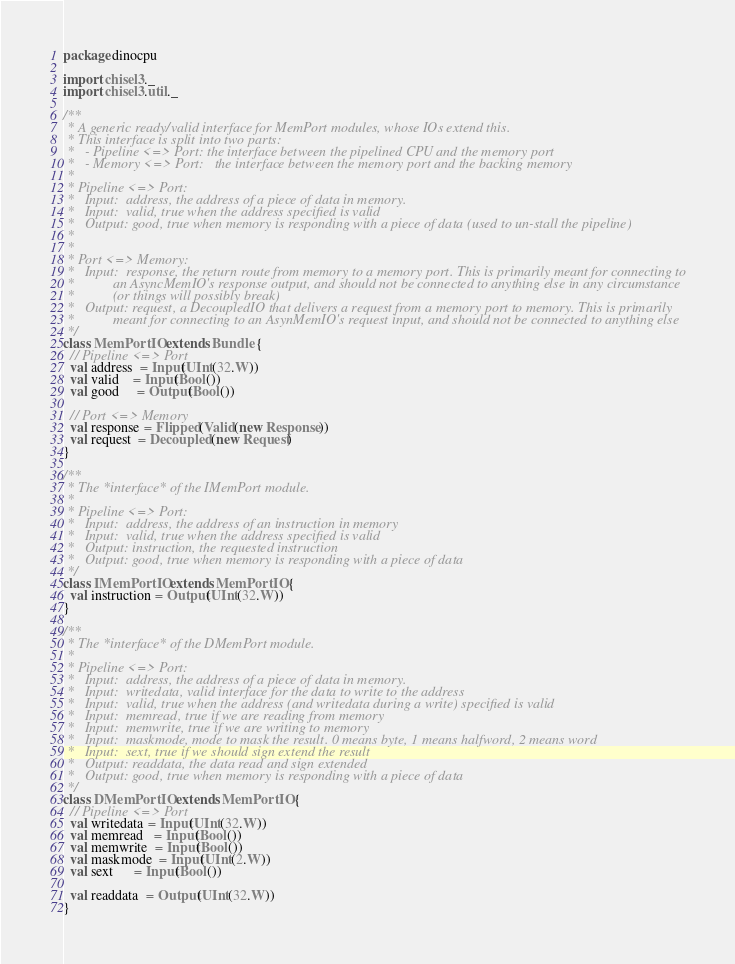<code> <loc_0><loc_0><loc_500><loc_500><_Scala_>
package dinocpu

import chisel3._
import chisel3.util._

/**
 * A generic ready/valid interface for MemPort modules, whose IOs extend this.
 * This interface is split into two parts:
 *   - Pipeline <=> Port: the interface between the pipelined CPU and the memory port
 *   - Memory <=> Port:   the interface between the memory port and the backing memory
 *
 * Pipeline <=> Port:
 *   Input:  address, the address of a piece of data in memory.
 *   Input:  valid, true when the address specified is valid
 *   Output: good, true when memory is responding with a piece of data (used to un-stall the pipeline)
 *
 *
 * Port <=> Memory:
 *   Input:  response, the return route from memory to a memory port. This is primarily meant for connecting to
 *           an AsyncMemIO's response output, and should not be connected to anything else in any circumstance
 *           (or things will possibly break)
 *   Output: request, a DecoupledIO that delivers a request from a memory port to memory. This is primarily
 *           meant for connecting to an AsynMemIO's request input, and should not be connected to anything else
 */
class MemPortIO extends Bundle {
  // Pipeline <=> Port
  val address  = Input(UInt(32.W))
  val valid    = Input(Bool())
  val good     = Output(Bool())

  // Port <=> Memory
  val response = Flipped(Valid(new Response))
  val request  = Decoupled(new Request)
}

/**
 * The *interface* of the IMemPort module.
 *
 * Pipeline <=> Port:
 *   Input:  address, the address of an instruction in memory
 *   Input:  valid, true when the address specified is valid
 *   Output: instruction, the requested instruction
 *   Output: good, true when memory is responding with a piece of data
 */
class IMemPortIO extends MemPortIO {
  val instruction = Output(UInt(32.W))
}

/**
 * The *interface* of the DMemPort module.
 *
 * Pipeline <=> Port:
 *   Input:  address, the address of a piece of data in memory.
 *   Input:  writedata, valid interface for the data to write to the address
 *   Input:  valid, true when the address (and writedata during a write) specified is valid
 *   Input:  memread, true if we are reading from memory
 *   Input:  memwrite, true if we are writing to memory
 *   Input:  maskmode, mode to mask the result. 0 means byte, 1 means halfword, 2 means word
 *   Input:  sext, true if we should sign extend the result
 *   Output: readdata, the data read and sign extended
 *   Output: good, true when memory is responding with a piece of data
 */
class DMemPortIO extends MemPortIO {
  // Pipeline <=> Port
  val writedata = Input(UInt(32.W))
  val memread   = Input(Bool())
  val memwrite  = Input(Bool())
  val maskmode  = Input(UInt(2.W))
  val sext      = Input(Bool())

  val readdata  = Output(UInt(32.W))
}
</code> 